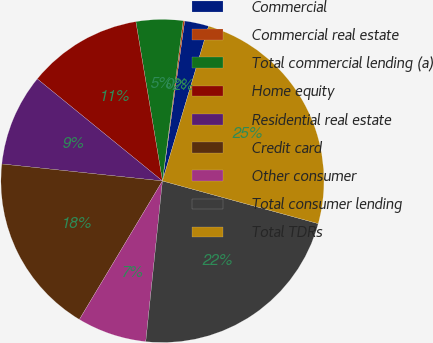Convert chart to OTSL. <chart><loc_0><loc_0><loc_500><loc_500><pie_chart><fcel>Commercial<fcel>Commercial real estate<fcel>Total commercial lending (a)<fcel>Home equity<fcel>Residential real estate<fcel>Credit card<fcel>Other consumer<fcel>Total consumer lending<fcel>Total TDRs<nl><fcel>2.41%<fcel>0.15%<fcel>4.68%<fcel>11.48%<fcel>9.21%<fcel>18.08%<fcel>6.95%<fcel>22.39%<fcel>24.65%<nl></chart> 